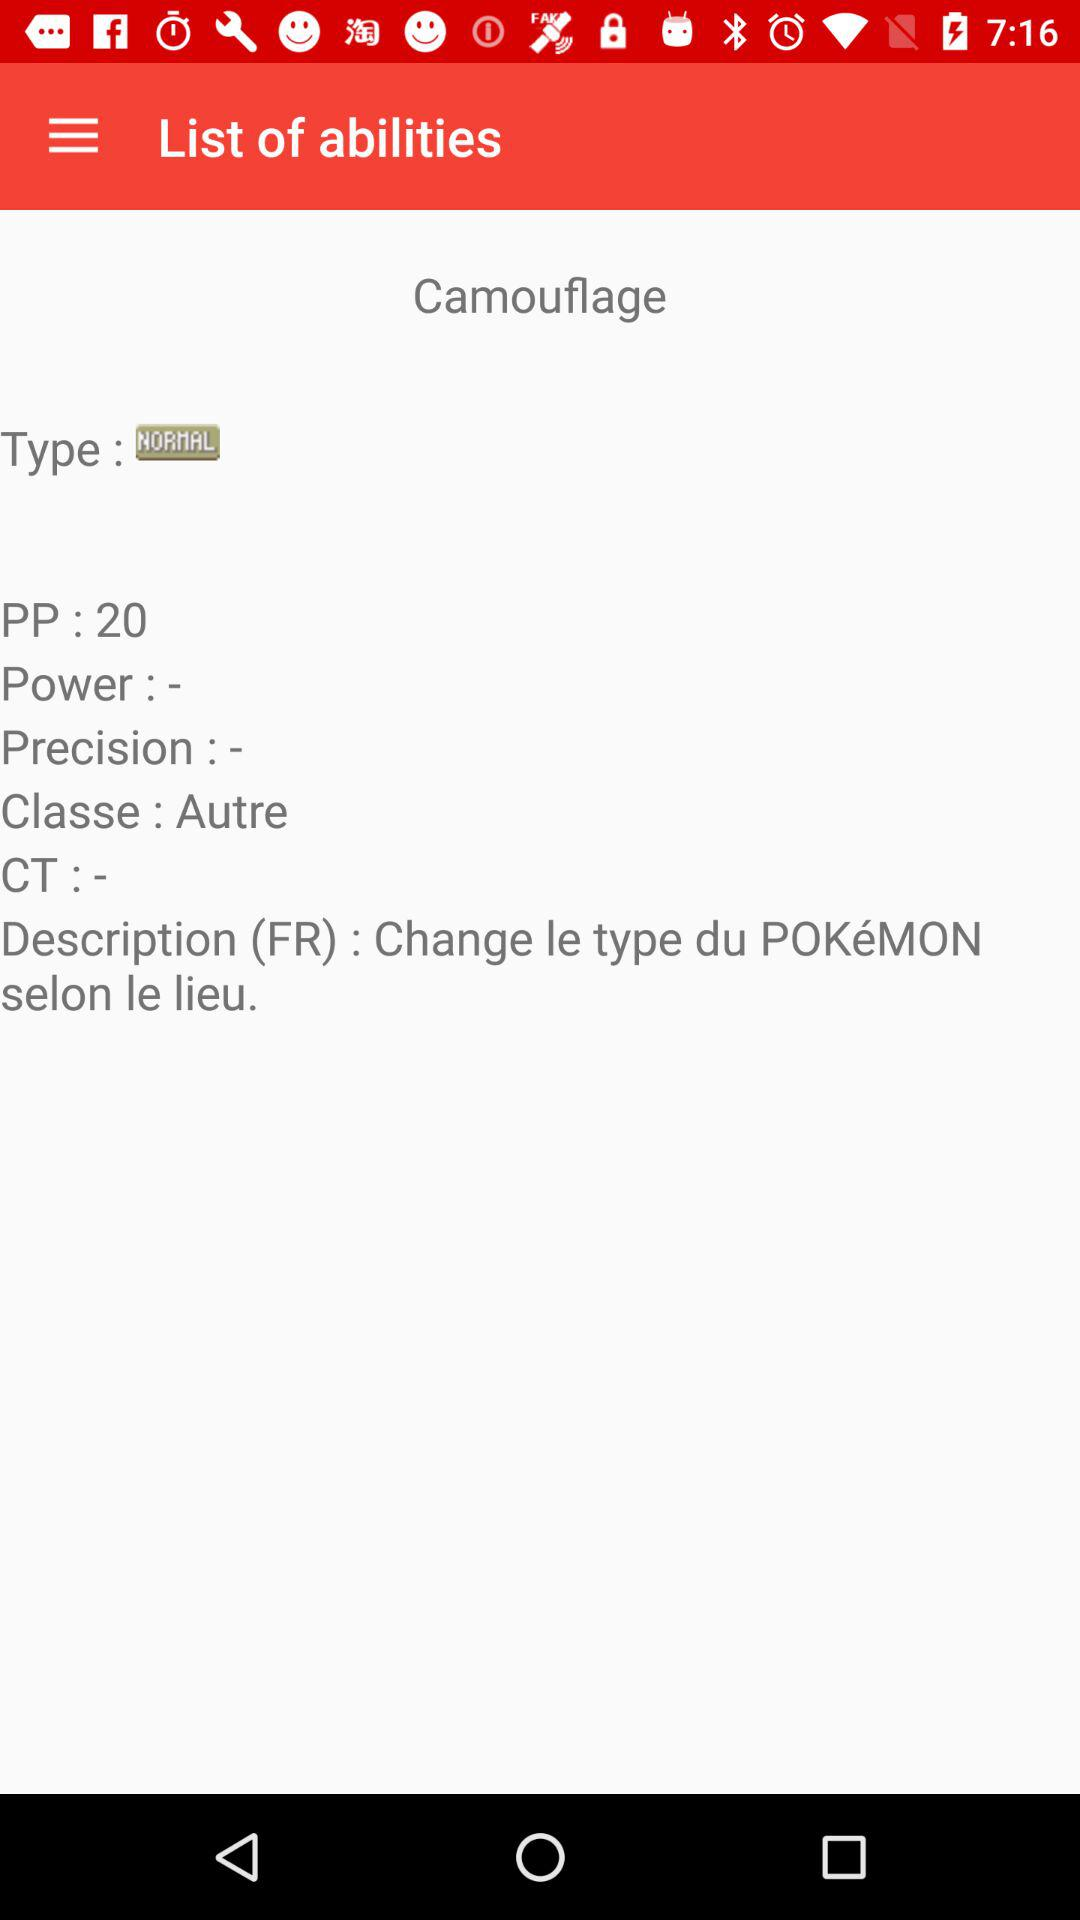What is the "Classe"? The "Classe" is "Autre". 